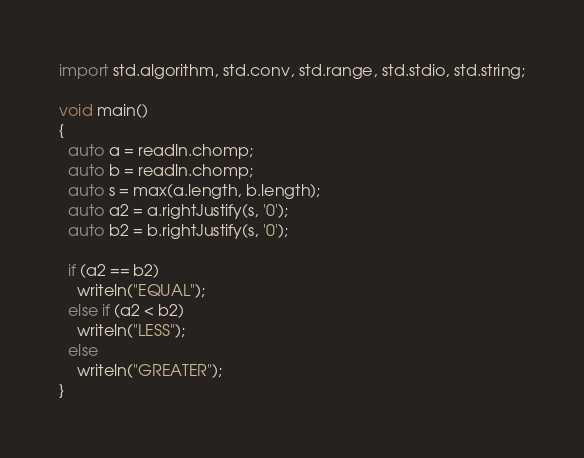Convert code to text. <code><loc_0><loc_0><loc_500><loc_500><_D_>import std.algorithm, std.conv, std.range, std.stdio, std.string;

void main()
{
  auto a = readln.chomp;
  auto b = readln.chomp;
  auto s = max(a.length, b.length);
  auto a2 = a.rightJustify(s, '0');
  auto b2 = b.rightJustify(s, '0');

  if (a2 == b2)
    writeln("EQUAL");
  else if (a2 < b2)
    writeln("LESS");
  else
    writeln("GREATER");
}
</code> 